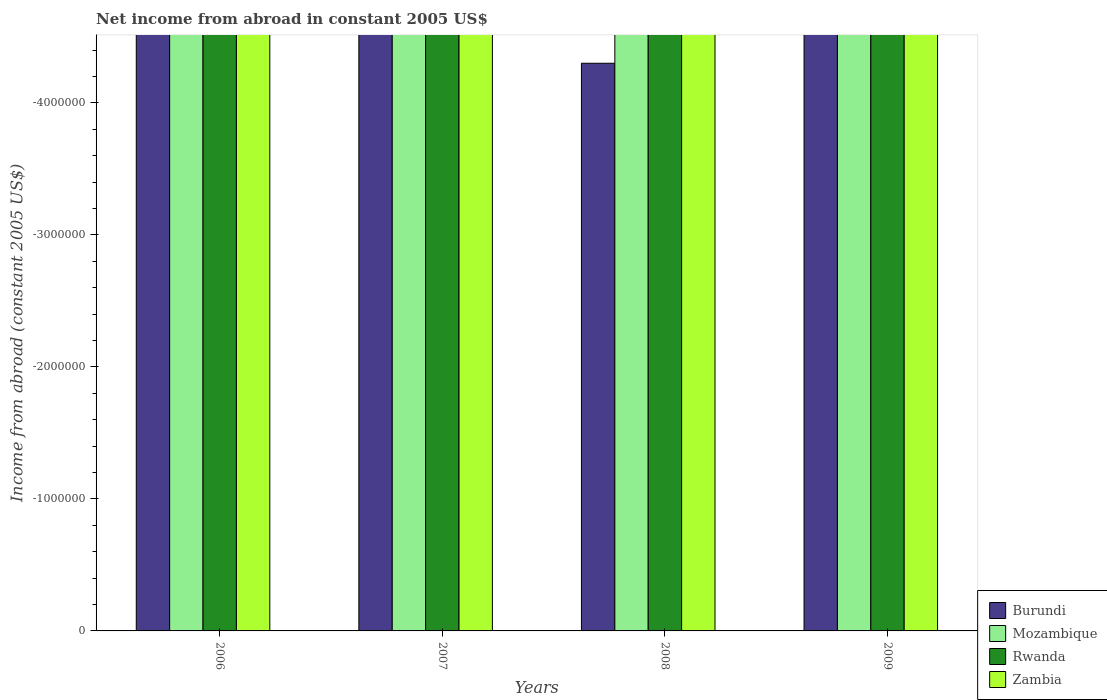How many different coloured bars are there?
Your response must be concise. 0. How many bars are there on the 1st tick from the left?
Give a very brief answer. 0. What is the label of the 3rd group of bars from the left?
Offer a very short reply. 2008. What is the average net income from abroad in Burundi per year?
Your answer should be very brief. 0. Is it the case that in every year, the sum of the net income from abroad in Rwanda and net income from abroad in Mozambique is greater than the sum of net income from abroad in Zambia and net income from abroad in Burundi?
Make the answer very short. No. Are all the bars in the graph horizontal?
Your answer should be very brief. No. What is the difference between two consecutive major ticks on the Y-axis?
Give a very brief answer. 1.00e+06. Does the graph contain any zero values?
Give a very brief answer. Yes. How are the legend labels stacked?
Ensure brevity in your answer.  Vertical. What is the title of the graph?
Keep it short and to the point. Net income from abroad in constant 2005 US$. What is the label or title of the Y-axis?
Ensure brevity in your answer.  Income from abroad (constant 2005 US$). What is the Income from abroad (constant 2005 US$) in Burundi in 2006?
Provide a succinct answer. 0. What is the Income from abroad (constant 2005 US$) in Rwanda in 2006?
Provide a short and direct response. 0. What is the Income from abroad (constant 2005 US$) in Mozambique in 2007?
Offer a terse response. 0. What is the Income from abroad (constant 2005 US$) of Burundi in 2008?
Your response must be concise. 0. What is the Income from abroad (constant 2005 US$) of Rwanda in 2009?
Your response must be concise. 0. What is the total Income from abroad (constant 2005 US$) in Burundi in the graph?
Offer a very short reply. 0. What is the total Income from abroad (constant 2005 US$) in Rwanda in the graph?
Give a very brief answer. 0. What is the total Income from abroad (constant 2005 US$) of Zambia in the graph?
Provide a short and direct response. 0. What is the average Income from abroad (constant 2005 US$) of Rwanda per year?
Provide a succinct answer. 0. What is the average Income from abroad (constant 2005 US$) in Zambia per year?
Your answer should be very brief. 0. 